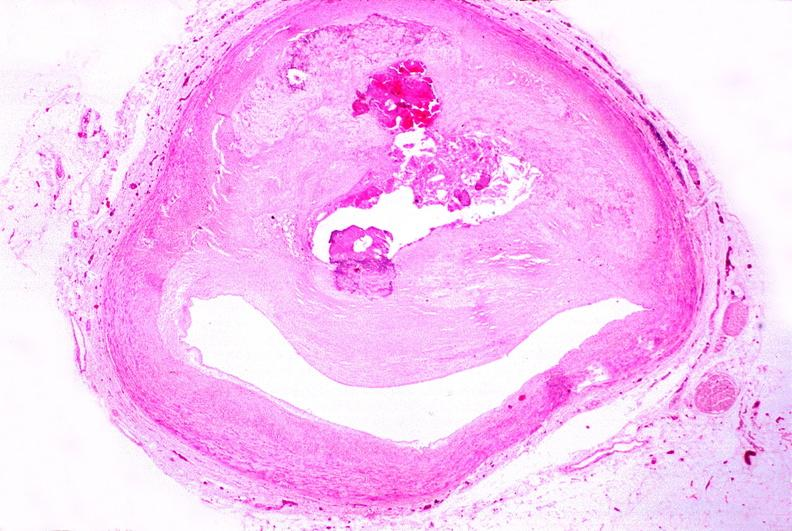what is present?
Answer the question using a single word or phrase. Cardiovascular 